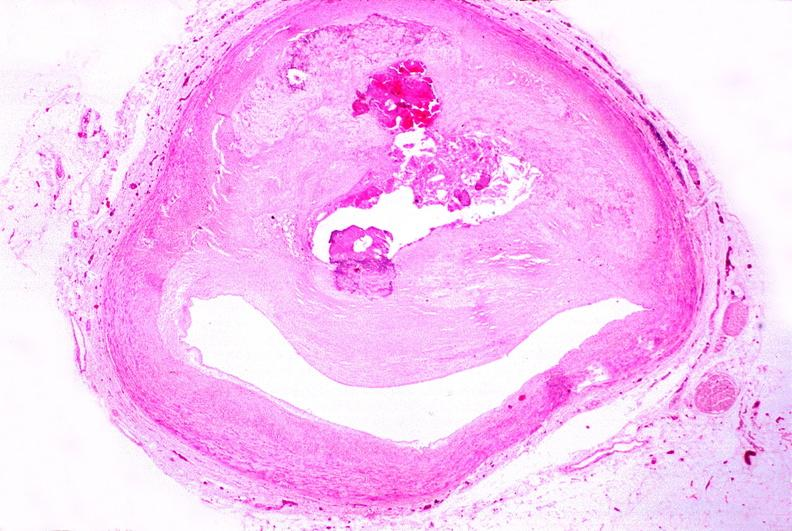what is present?
Answer the question using a single word or phrase. Cardiovascular 